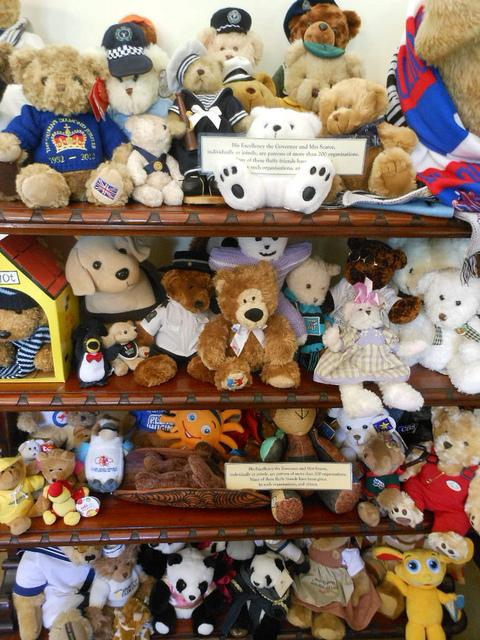What does the person who owns the shelves like to collect? stuffed animals 